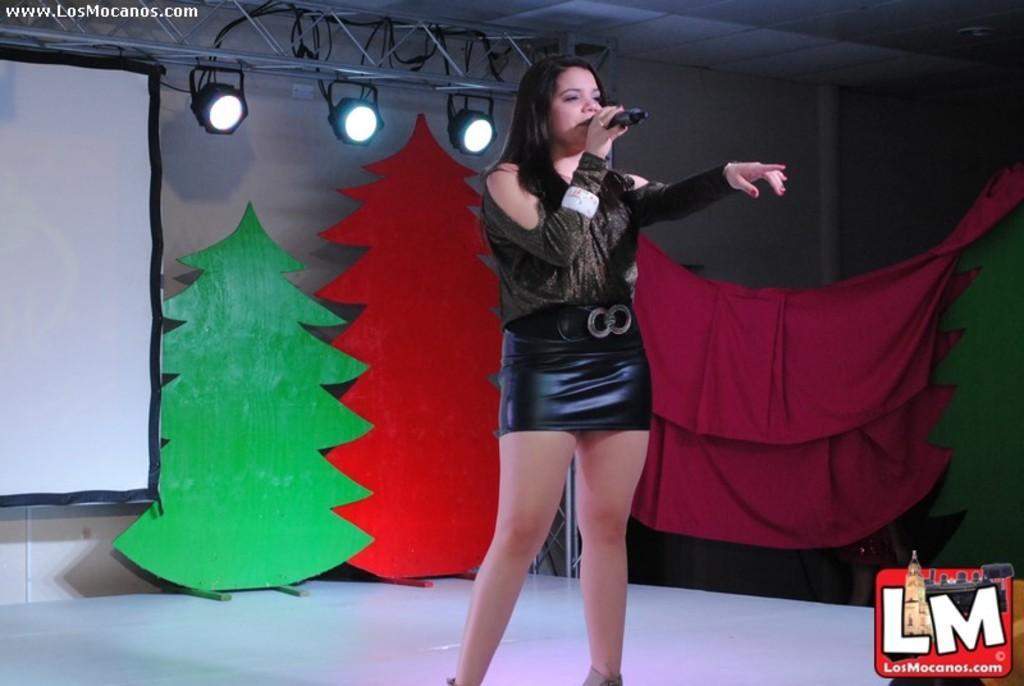In one or two sentences, can you explain what this image depicts? In this picture there is a woman standing wearing a black color dress and holding a mic in her hand. Behind her there are two artificially made trees which were in green and red color. We can observe a pink color cloth here. In the left side there is a projector display screen. In the background there is a wall. 